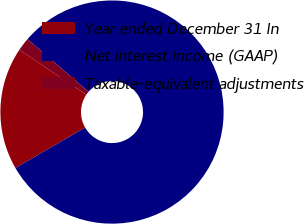Convert chart. <chart><loc_0><loc_0><loc_500><loc_500><pie_chart><fcel>Year ended December 31 In<fcel>Net interest income (GAAP)<fcel>Taxable-equivalent adjustments<nl><fcel>17.79%<fcel>80.32%<fcel>1.9%<nl></chart> 